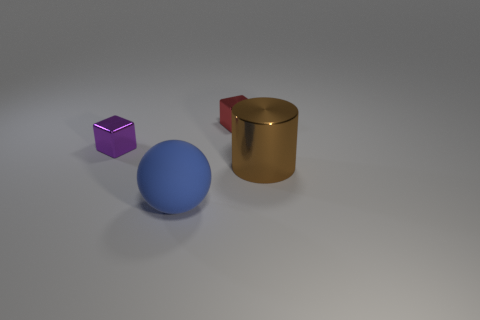Add 4 big cyan cubes. How many objects exist? 8 Subtract all cylinders. How many objects are left? 3 Add 1 purple metallic objects. How many purple metallic objects are left? 2 Add 2 big cyan blocks. How many big cyan blocks exist? 2 Subtract 0 cyan cylinders. How many objects are left? 4 Subtract all red shiny cubes. Subtract all shiny things. How many objects are left? 0 